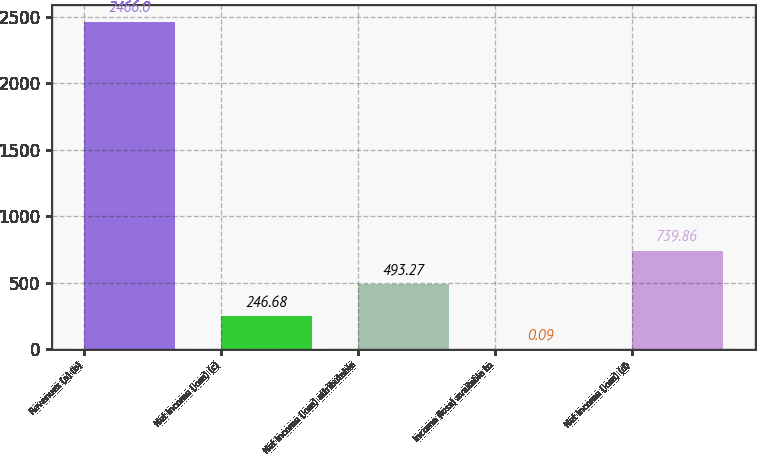Convert chart. <chart><loc_0><loc_0><loc_500><loc_500><bar_chart><fcel>Revenues (a) (b)<fcel>Net income (loss) (c)<fcel>Net income (loss) attributable<fcel>Income (loss) available to<fcel>Net income (loss) (d)<nl><fcel>2466<fcel>246.68<fcel>493.27<fcel>0.09<fcel>739.86<nl></chart> 